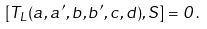Convert formula to latex. <formula><loc_0><loc_0><loc_500><loc_500>[ T _ { L } ( a , a ^ { \prime } , b , b ^ { \prime } , c , d ) , S ] = 0 \, .</formula> 